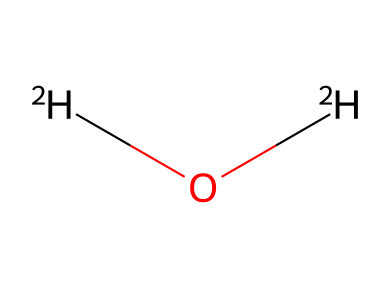What is the name of the chemical represented by this structure? The structure contains two deuterium atoms and one oxygen atom, which is characteristic of heavy water. Heavy water's chemical name is deuterium oxide.
Answer: deuterium oxide How many hydrogen atoms are present in this chemical structure? The structure shows two deuterium atoms (each represented as [2H]), which are isotopes of hydrogen. Therefore, there are two hydrogen atoms.
Answer: 2 What type of bonds connect the atoms in this chemical? The chemical structure indicates that the oxygen is connected to the two deuterium atoms, forming covalent bonds. Covalent bonds are formed by sharing electrons between atoms.
Answer: covalent What is the molecular formula for this compound? The SMILES notation indicates one oxygen atom and two deuterium atoms. The molecular formula is thus represented as D2O, where D stands for deuterium.
Answer: D2O If this compound is found in a marine environment, what could be its effect on marine life? Heavy water can affect biological processes due to its different physical properties compared to regular water. It can cause changes in metabolic rates and affect organisms due to its density and bonding characteristics.
Answer: changes in metabolism What makes deuterium oxide different from regular water? Deuterium oxide has a different isotope of hydrogen (deuterium) which has one neutron, making it heavier than regular water that contains protium, the most common hydrogen isotope. This difference affects its physical and chemical properties.
Answer: heavier isotopic composition Why is heavy water important in scientific research? Heavy water is used mainly as a neutron moderator in nuclear reactors and in various types of scientific research, particularly in studies involving isotopic labeling and tracing. Its unique properties make it valuable in these applications.
Answer: neutron moderator 